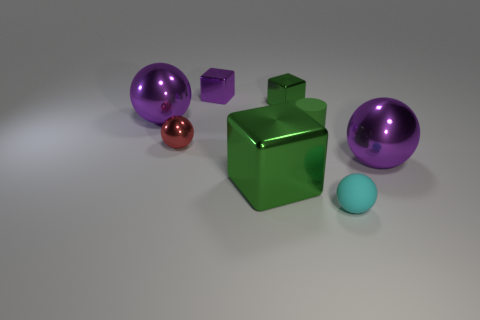There is a rubber thing to the left of the tiny object that is to the right of the small cylinder behind the red shiny sphere; what size is it?
Offer a very short reply. Small. Is there a purple metallic ball left of the small sphere in front of the big cube?
Keep it short and to the point. Yes. What number of tiny things are in front of the purple shiny object in front of the small red metal thing in front of the tiny purple object?
Ensure brevity in your answer.  1. The object that is both behind the cylinder and left of the tiny purple shiny cube is what color?
Offer a terse response. Purple. How many big cubes are the same color as the matte cylinder?
Your response must be concise. 1. What number of balls are either green shiny objects or small shiny objects?
Make the answer very short. 1. What color is the rubber ball that is the same size as the green matte cylinder?
Provide a short and direct response. Cyan. There is a big purple ball on the left side of the cube that is in front of the matte cylinder; is there a small cylinder that is behind it?
Offer a very short reply. No. The green matte cylinder is what size?
Give a very brief answer. Small. What number of things are either tiny cyan rubber things or tiny green cylinders?
Give a very brief answer. 2. 